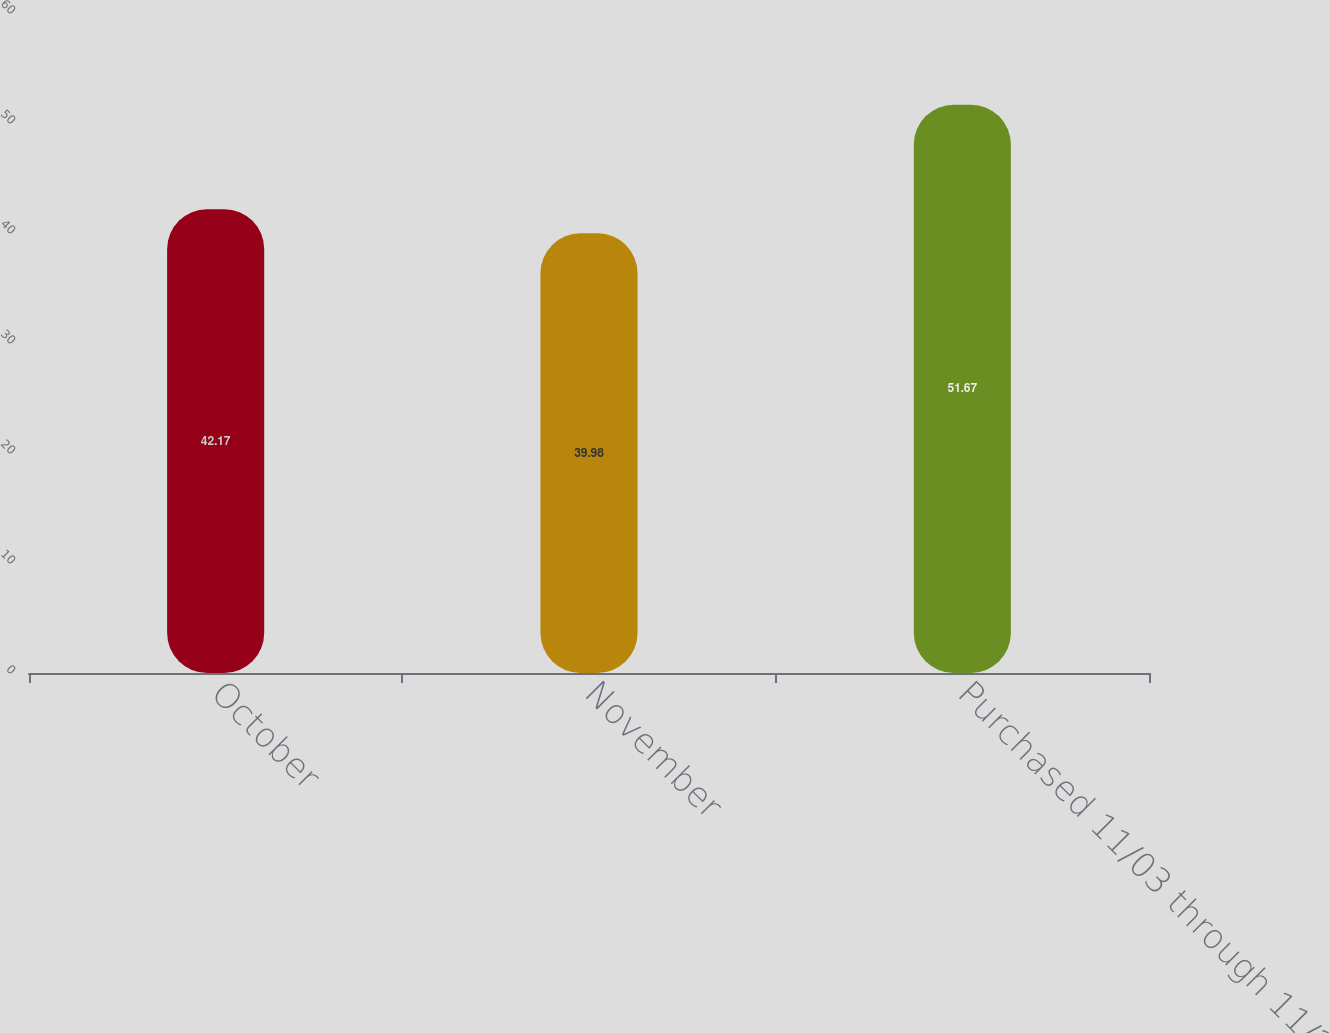Convert chart to OTSL. <chart><loc_0><loc_0><loc_500><loc_500><bar_chart><fcel>October<fcel>November<fcel>Purchased 11/03 through 11/28<nl><fcel>42.17<fcel>39.98<fcel>51.67<nl></chart> 